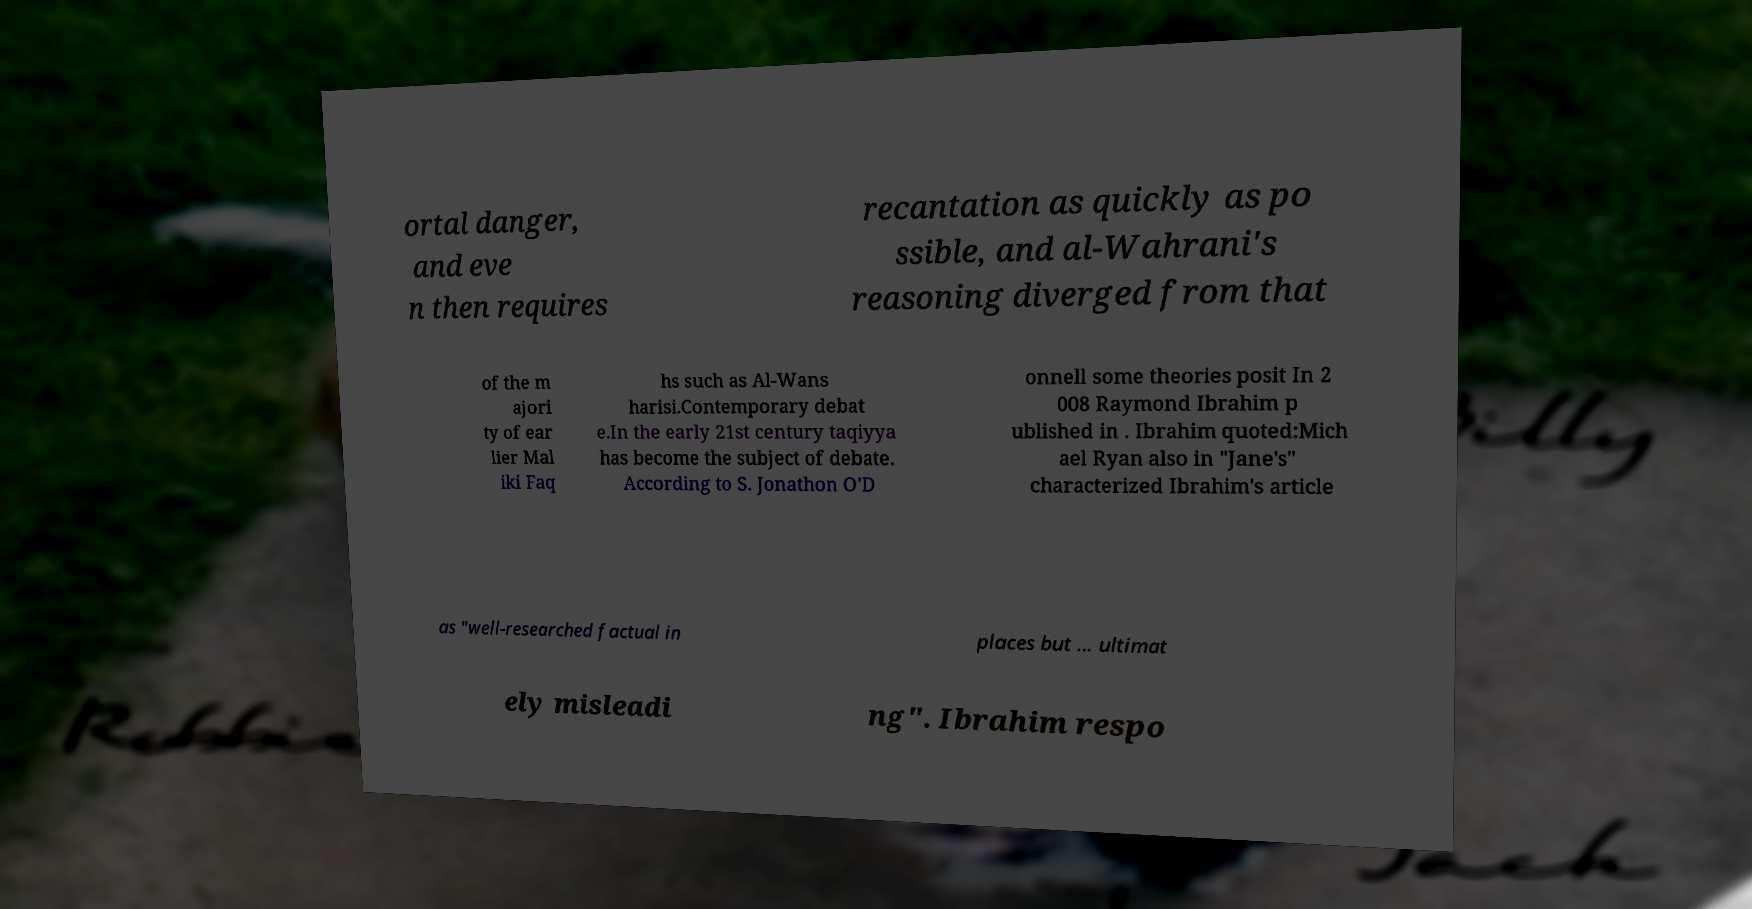I need the written content from this picture converted into text. Can you do that? ortal danger, and eve n then requires recantation as quickly as po ssible, and al-Wahrani's reasoning diverged from that of the m ajori ty of ear lier Mal iki Faq hs such as Al-Wans harisi.Contemporary debat e.In the early 21st century taqiyya has become the subject of debate. According to S. Jonathon O'D onnell some theories posit In 2 008 Raymond Ibrahim p ublished in . Ibrahim quoted:Mich ael Ryan also in "Jane's" characterized Ibrahim's article as "well-researched factual in places but ... ultimat ely misleadi ng". Ibrahim respo 